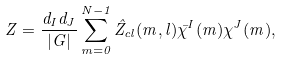<formula> <loc_0><loc_0><loc_500><loc_500>Z = \frac { d _ { I } d _ { J } } { | G | } \sum _ { m = 0 } ^ { N - 1 } \hat { Z } _ { c l } ( m , l ) \bar { \chi } ^ { I } ( m ) \chi ^ { J } ( m ) ,</formula> 